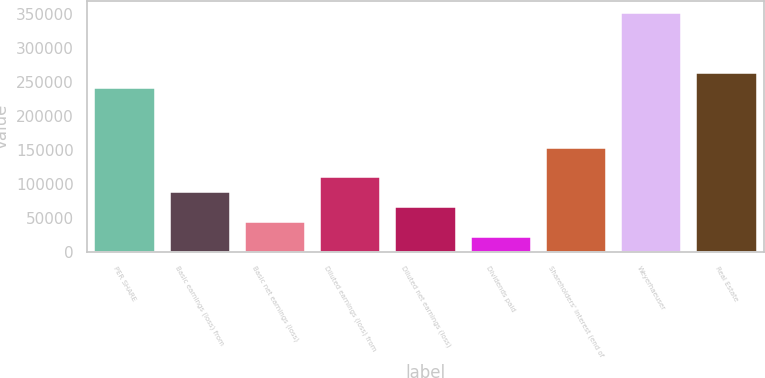<chart> <loc_0><loc_0><loc_500><loc_500><bar_chart><fcel>PER SHARE<fcel>Basic earnings (loss) from<fcel>Basic net earnings (loss)<fcel>Diluted earnings (loss) from<fcel>Diluted net earnings (loss)<fcel>Dividends paid<fcel>Shareholders' interest (end of<fcel>Weyerhaeuser<fcel>Real Estate<nl><fcel>241235<fcel>87722.7<fcel>43861.9<fcel>109653<fcel>65792.3<fcel>21931.5<fcel>153514<fcel>350887<fcel>263166<nl></chart> 